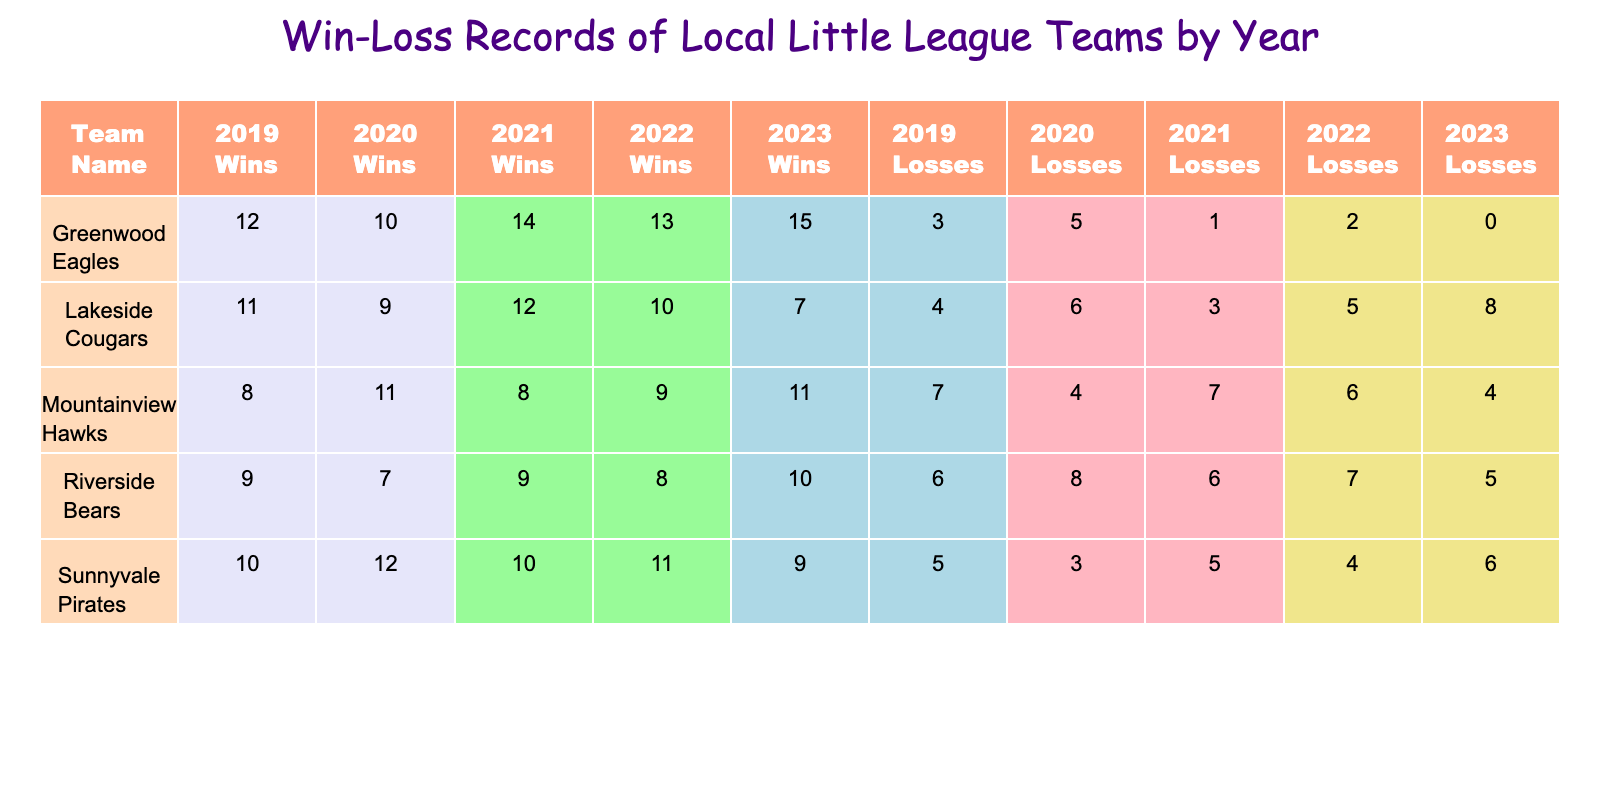What was the winning percentage of the Greenwood Eagles in 2021? The Greenwood Eagles had 14 wins and 1 loss in 2021. To find the winning percentage, we use the formula (Wins / (Wins + Losses)) * 100. This gives us (14 / (14 + 1)) * 100 = (14 / 15) * 100 = 93.33%.
Answer: 93.33% Which team had the most losses in 2020? Looking at the 2020 data, the team with the most losses was the Riverside Bears with 8 losses.
Answer: Riverside Bears Did the Sunnyvale Pirates improve their wins from 2019 to 2020? In 2019, the Sunnyvale Pirates had 10 wins, and in 2020, they had 12 wins. Since 12 is greater than 10, this shows an improvement in their wins.
Answer: Yes What is the total number of wins for the Lakeside Cougars from 2019 to 2023? The Lakeside Cougars had 11 wins in 2019, 9 wins in 2020, 12 wins in 2021, 10 wins in 2022, and 7 wins in 2023. Adding these gives 11 + 9 + 12 + 10 + 7 = 49 total wins.
Answer: 49 Which team had a perfect season with no losses, and in which year did they achieve this? The Greenwood Eagles had a perfect season in 2023 with 15 wins and 0 losses.
Answer: Greenwood Eagles in 2023 What is the average number of wins for the Mountainview Hawks over the years? The Mountainview Hawks had 8 wins in 2019, 11 wins in 2020, 8 wins in 2021, 9 wins in 2022, and 11 wins in 2023. The sum is 8 + 11 + 8 + 9 + 11 = 47, and there are 5 data points. The average is 47 / 5 = 9.4.
Answer: 9.4 How many teams had a record of 10 or more wins in 2022? The teams with 10 or more wins in 2022 were the Greenwood Eagles (13), Sunnyvale Pirates (11), and Lakeside Cougars (10). This totals to 3 teams.
Answer: 3 Did the Riverside Bears have a winning record in 2021? In 2021, the Riverside Bears had 9 wins and 6 losses. This means they won more games than they lost, giving them a winning record.
Answer: Yes What was the trend in wins for the Greenwood Eagles from 2019 to 2023? The Greenwood Eagles had the following wins: 12 in 2019, 10 in 2020, 14 in 2021, 13 in 2022, and finally 15 in 2023. The trend shows an increase over these years, peaking at 15 in 2023.
Answer: Increasing trend 